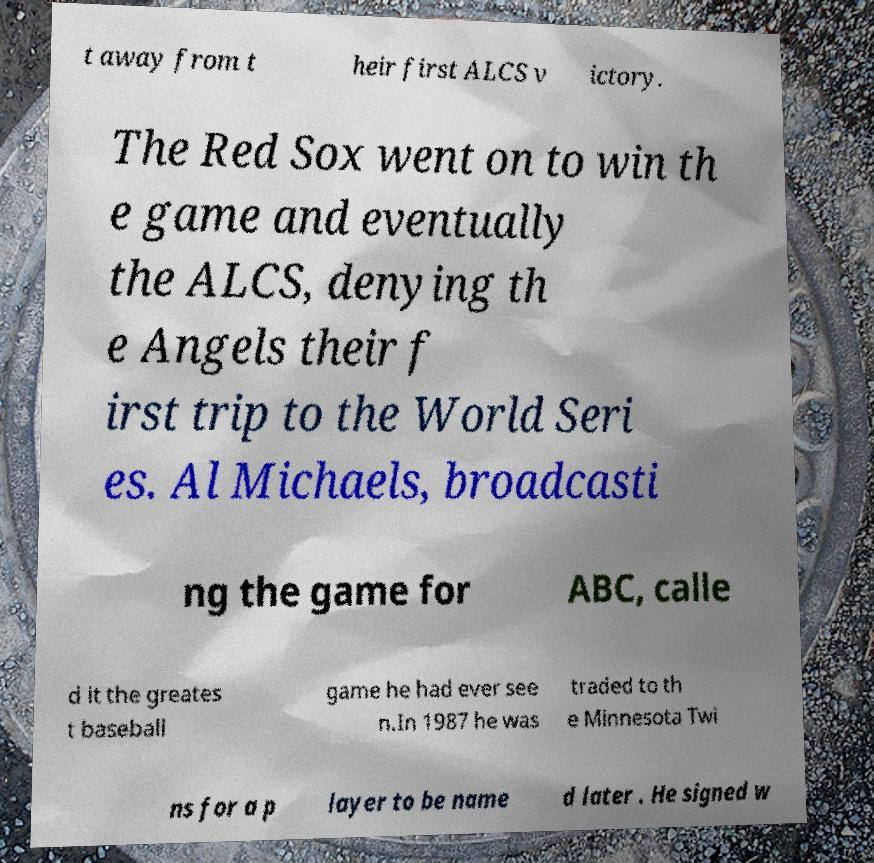Can you accurately transcribe the text from the provided image for me? t away from t heir first ALCS v ictory. The Red Sox went on to win th e game and eventually the ALCS, denying th e Angels their f irst trip to the World Seri es. Al Michaels, broadcasti ng the game for ABC, calle d it the greates t baseball game he had ever see n.In 1987 he was traded to th e Minnesota Twi ns for a p layer to be name d later . He signed w 